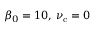Convert formula to latex. <formula><loc_0><loc_0><loc_500><loc_500>\beta _ { 0 } = 1 0 , \, \nu _ { c } = 0</formula> 